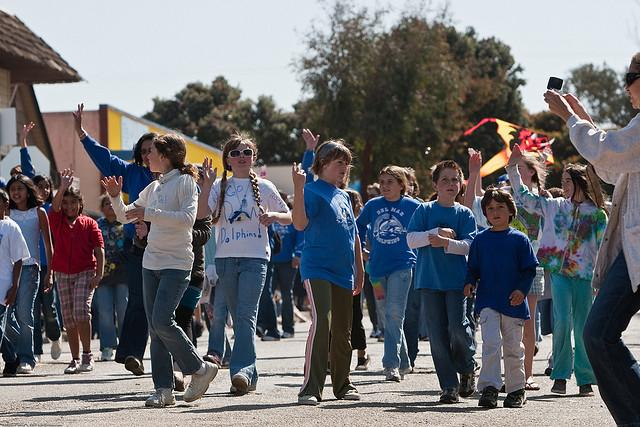Why is the woman on the right holding an object in her hands? taking picture 